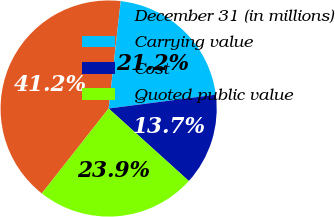Convert chart to OTSL. <chart><loc_0><loc_0><loc_500><loc_500><pie_chart><fcel>December 31 (in millions)<fcel>Carrying value<fcel>Cost<fcel>Quoted public value<nl><fcel>41.17%<fcel>21.17%<fcel>13.74%<fcel>23.91%<nl></chart> 